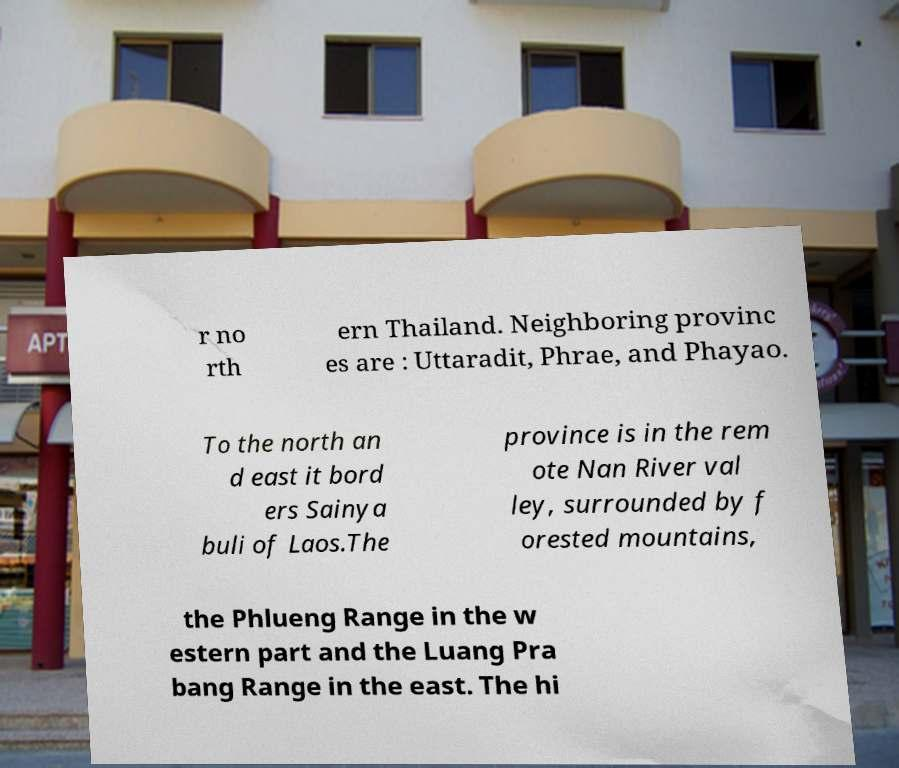Can you read and provide the text displayed in the image?This photo seems to have some interesting text. Can you extract and type it out for me? r no rth ern Thailand. Neighboring provinc es are : Uttaradit, Phrae, and Phayao. To the north an d east it bord ers Sainya buli of Laos.The province is in the rem ote Nan River val ley, surrounded by f orested mountains, the Phlueng Range in the w estern part and the Luang Pra bang Range in the east. The hi 